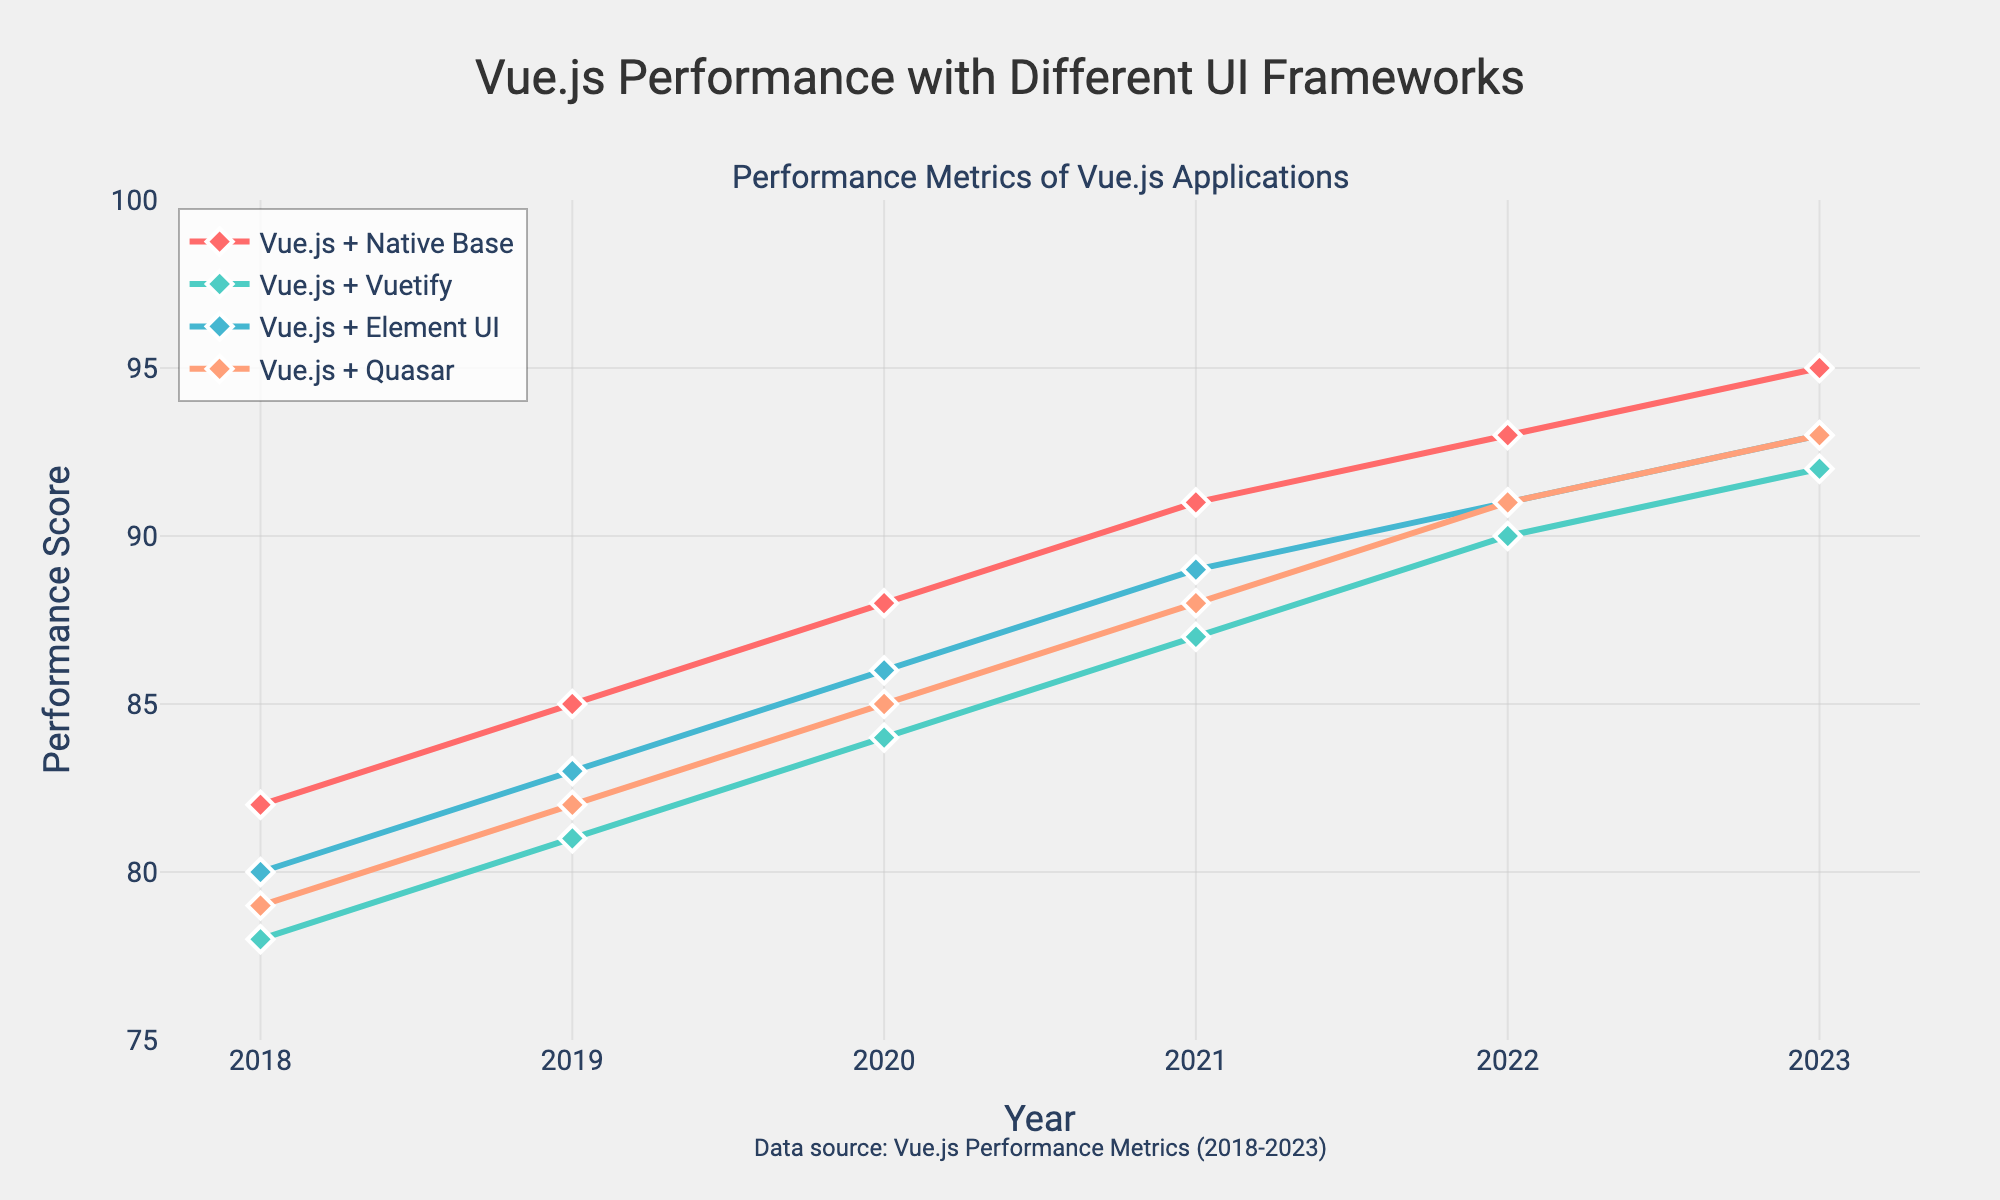Which year had the highest performance score for Vue.js applications using Native Base? Look at the curve for "Vue.js + Native Base" and find the peak. It reaches its highest point in 2023 with a score of 95.
Answer: 2023 What is the difference in performance scores between Vue.js + Vuetify and Vue.js + Quasar in 2018? Subtract the performance score of "Vue.js + Quasar" from that of "Vue.js + Vuetify" in 2018. 78 - 79 = -1.
Answer: -1 Which UI framework had the lowest performance score in 2022? Compare the 2022 scores of each line. "Vue.js + Vuetify" has the lowest score in 2022 with a value of 90.
Answer: Vue.js + Vuetify How much did the performance score of Vue.js + Element UI increase from 2018 to 2023? Subtract the 2018 score of "Vue.js + Element UI" from the 2023 score. 93 - 80 = 13.
Answer: 13 What is the average performance score of Vue.js + Native Base from 2018 to 2023? Sum the yearly scores for "Vue.js + Native Base" from 2018 to 2023 and divide by the number of years. (82 + 85 + 88 + 91 + 93 + 95) / 6 = 89.
Answer: 89 Which year shows the smallest performance difference between Vue.js + Element UI and Vue.js + Native Base? Calculate the difference for each year, then find the smallest one. In 2020, the difference is smallest:
Answer: 2020 By how much did Vue.js + Quasar outperform Vue.js + Vuetify in 2019? Subtract the performance score of "Vue.js + Vuetify" from that of "Vue.js + Quasar" in 2019. 82 - 81 = 1.
Answer: 1 What color represents Vue.js + Element UI in the chart? Identify the color corresponding to "Vue.js + Element UI" in the legend. It is represented by blue.
Answer: Blue 